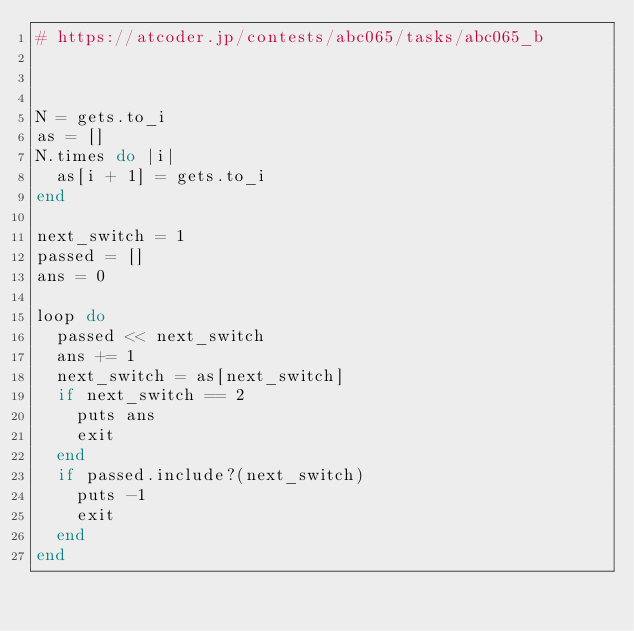<code> <loc_0><loc_0><loc_500><loc_500><_Ruby_># https://atcoder.jp/contests/abc065/tasks/abc065_b



N = gets.to_i
as = []
N.times do |i|
  as[i + 1] = gets.to_i
end

next_switch = 1
passed = []
ans = 0

loop do
  passed << next_switch
  ans += 1
  next_switch = as[next_switch]
  if next_switch == 2
    puts ans
    exit
  end
  if passed.include?(next_switch)
    puts -1
    exit
  end
end
</code> 